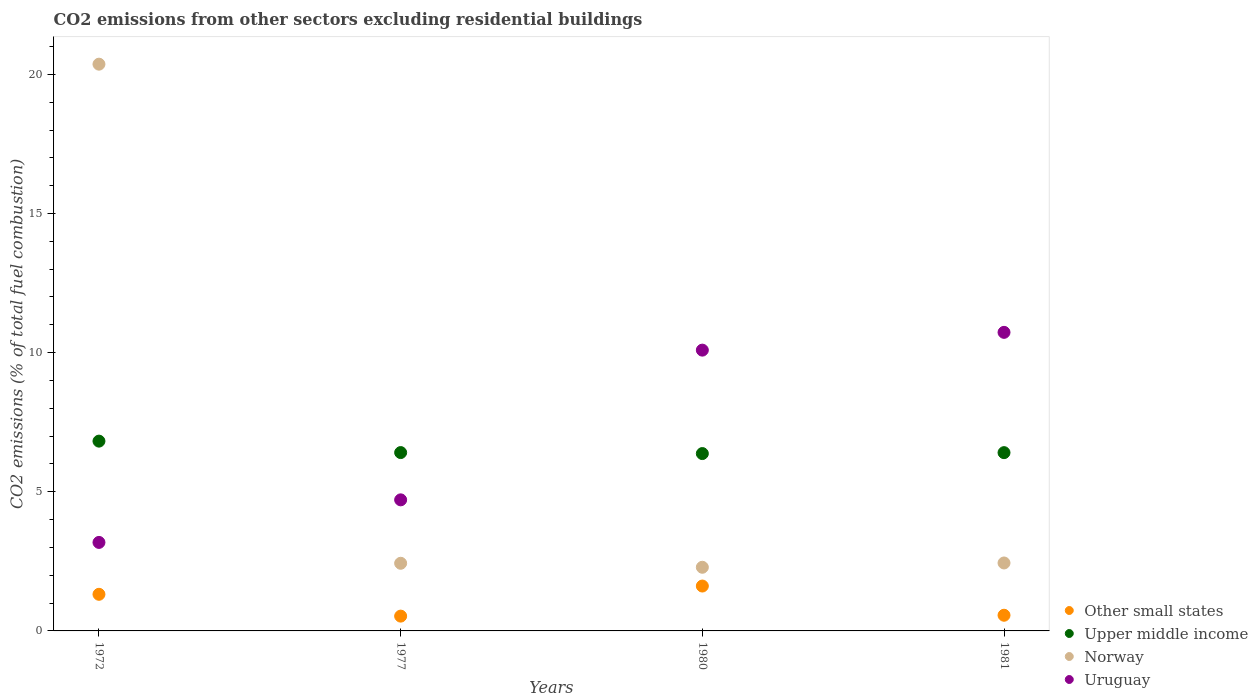How many different coloured dotlines are there?
Your answer should be very brief. 4. Is the number of dotlines equal to the number of legend labels?
Your response must be concise. Yes. What is the total CO2 emitted in Other small states in 1980?
Ensure brevity in your answer.  1.61. Across all years, what is the maximum total CO2 emitted in Norway?
Offer a terse response. 20.37. Across all years, what is the minimum total CO2 emitted in Other small states?
Make the answer very short. 0.53. In which year was the total CO2 emitted in Other small states maximum?
Provide a succinct answer. 1980. In which year was the total CO2 emitted in Uruguay minimum?
Provide a short and direct response. 1972. What is the total total CO2 emitted in Other small states in the graph?
Make the answer very short. 4.02. What is the difference between the total CO2 emitted in Other small states in 1972 and that in 1977?
Keep it short and to the point. 0.78. What is the difference between the total CO2 emitted in Norway in 1980 and the total CO2 emitted in Upper middle income in 1977?
Provide a short and direct response. -4.12. What is the average total CO2 emitted in Upper middle income per year?
Ensure brevity in your answer.  6.5. In the year 1972, what is the difference between the total CO2 emitted in Upper middle income and total CO2 emitted in Norway?
Keep it short and to the point. -13.55. What is the ratio of the total CO2 emitted in Uruguay in 1972 to that in 1980?
Make the answer very short. 0.32. Is the total CO2 emitted in Upper middle income in 1972 less than that in 1980?
Offer a very short reply. No. What is the difference between the highest and the second highest total CO2 emitted in Other small states?
Keep it short and to the point. 0.3. What is the difference between the highest and the lowest total CO2 emitted in Norway?
Give a very brief answer. 18.08. In how many years, is the total CO2 emitted in Upper middle income greater than the average total CO2 emitted in Upper middle income taken over all years?
Provide a succinct answer. 1. Is it the case that in every year, the sum of the total CO2 emitted in Upper middle income and total CO2 emitted in Norway  is greater than the total CO2 emitted in Other small states?
Give a very brief answer. Yes. Is the total CO2 emitted in Norway strictly less than the total CO2 emitted in Uruguay over the years?
Give a very brief answer. No. How many dotlines are there?
Make the answer very short. 4. Does the graph contain grids?
Keep it short and to the point. No. Where does the legend appear in the graph?
Your answer should be compact. Bottom right. What is the title of the graph?
Your answer should be compact. CO2 emissions from other sectors excluding residential buildings. Does "East Asia (developing only)" appear as one of the legend labels in the graph?
Provide a short and direct response. No. What is the label or title of the X-axis?
Provide a short and direct response. Years. What is the label or title of the Y-axis?
Your answer should be very brief. CO2 emissions (% of total fuel combustion). What is the CO2 emissions (% of total fuel combustion) of Other small states in 1972?
Offer a terse response. 1.32. What is the CO2 emissions (% of total fuel combustion) of Upper middle income in 1972?
Your answer should be compact. 6.82. What is the CO2 emissions (% of total fuel combustion) in Norway in 1972?
Provide a short and direct response. 20.37. What is the CO2 emissions (% of total fuel combustion) in Uruguay in 1972?
Offer a terse response. 3.18. What is the CO2 emissions (% of total fuel combustion) in Other small states in 1977?
Your response must be concise. 0.53. What is the CO2 emissions (% of total fuel combustion) in Upper middle income in 1977?
Offer a terse response. 6.41. What is the CO2 emissions (% of total fuel combustion) of Norway in 1977?
Your answer should be very brief. 2.43. What is the CO2 emissions (% of total fuel combustion) in Uruguay in 1977?
Keep it short and to the point. 4.71. What is the CO2 emissions (% of total fuel combustion) in Other small states in 1980?
Your answer should be compact. 1.61. What is the CO2 emissions (% of total fuel combustion) of Upper middle income in 1980?
Your answer should be very brief. 6.37. What is the CO2 emissions (% of total fuel combustion) of Norway in 1980?
Keep it short and to the point. 2.29. What is the CO2 emissions (% of total fuel combustion) of Uruguay in 1980?
Provide a succinct answer. 10.09. What is the CO2 emissions (% of total fuel combustion) of Other small states in 1981?
Offer a very short reply. 0.56. What is the CO2 emissions (% of total fuel combustion) in Upper middle income in 1981?
Your response must be concise. 6.41. What is the CO2 emissions (% of total fuel combustion) of Norway in 1981?
Make the answer very short. 2.44. What is the CO2 emissions (% of total fuel combustion) of Uruguay in 1981?
Offer a terse response. 10.73. Across all years, what is the maximum CO2 emissions (% of total fuel combustion) in Other small states?
Make the answer very short. 1.61. Across all years, what is the maximum CO2 emissions (% of total fuel combustion) of Upper middle income?
Offer a terse response. 6.82. Across all years, what is the maximum CO2 emissions (% of total fuel combustion) in Norway?
Make the answer very short. 20.37. Across all years, what is the maximum CO2 emissions (% of total fuel combustion) in Uruguay?
Make the answer very short. 10.73. Across all years, what is the minimum CO2 emissions (% of total fuel combustion) of Other small states?
Ensure brevity in your answer.  0.53. Across all years, what is the minimum CO2 emissions (% of total fuel combustion) of Upper middle income?
Provide a short and direct response. 6.37. Across all years, what is the minimum CO2 emissions (% of total fuel combustion) of Norway?
Ensure brevity in your answer.  2.29. Across all years, what is the minimum CO2 emissions (% of total fuel combustion) of Uruguay?
Give a very brief answer. 3.18. What is the total CO2 emissions (% of total fuel combustion) in Other small states in the graph?
Your response must be concise. 4.02. What is the total CO2 emissions (% of total fuel combustion) in Upper middle income in the graph?
Your response must be concise. 26.01. What is the total CO2 emissions (% of total fuel combustion) of Norway in the graph?
Make the answer very short. 27.53. What is the total CO2 emissions (% of total fuel combustion) in Uruguay in the graph?
Your answer should be compact. 28.71. What is the difference between the CO2 emissions (% of total fuel combustion) in Other small states in 1972 and that in 1977?
Ensure brevity in your answer.  0.78. What is the difference between the CO2 emissions (% of total fuel combustion) in Upper middle income in 1972 and that in 1977?
Ensure brevity in your answer.  0.41. What is the difference between the CO2 emissions (% of total fuel combustion) of Norway in 1972 and that in 1977?
Your answer should be very brief. 17.93. What is the difference between the CO2 emissions (% of total fuel combustion) in Uruguay in 1972 and that in 1977?
Make the answer very short. -1.53. What is the difference between the CO2 emissions (% of total fuel combustion) of Other small states in 1972 and that in 1980?
Provide a succinct answer. -0.3. What is the difference between the CO2 emissions (% of total fuel combustion) of Upper middle income in 1972 and that in 1980?
Give a very brief answer. 0.45. What is the difference between the CO2 emissions (% of total fuel combustion) of Norway in 1972 and that in 1980?
Offer a terse response. 18.08. What is the difference between the CO2 emissions (% of total fuel combustion) of Uruguay in 1972 and that in 1980?
Your response must be concise. -6.91. What is the difference between the CO2 emissions (% of total fuel combustion) of Other small states in 1972 and that in 1981?
Provide a short and direct response. 0.75. What is the difference between the CO2 emissions (% of total fuel combustion) in Upper middle income in 1972 and that in 1981?
Your response must be concise. 0.41. What is the difference between the CO2 emissions (% of total fuel combustion) of Norway in 1972 and that in 1981?
Provide a succinct answer. 17.92. What is the difference between the CO2 emissions (% of total fuel combustion) in Uruguay in 1972 and that in 1981?
Offer a very short reply. -7.55. What is the difference between the CO2 emissions (% of total fuel combustion) of Other small states in 1977 and that in 1980?
Your response must be concise. -1.08. What is the difference between the CO2 emissions (% of total fuel combustion) in Upper middle income in 1977 and that in 1980?
Make the answer very short. 0.04. What is the difference between the CO2 emissions (% of total fuel combustion) of Norway in 1977 and that in 1980?
Keep it short and to the point. 0.14. What is the difference between the CO2 emissions (% of total fuel combustion) of Uruguay in 1977 and that in 1980?
Your answer should be very brief. -5.38. What is the difference between the CO2 emissions (% of total fuel combustion) in Other small states in 1977 and that in 1981?
Your response must be concise. -0.03. What is the difference between the CO2 emissions (% of total fuel combustion) of Upper middle income in 1977 and that in 1981?
Provide a short and direct response. 0. What is the difference between the CO2 emissions (% of total fuel combustion) of Norway in 1977 and that in 1981?
Your answer should be very brief. -0.01. What is the difference between the CO2 emissions (% of total fuel combustion) of Uruguay in 1977 and that in 1981?
Offer a very short reply. -6.02. What is the difference between the CO2 emissions (% of total fuel combustion) of Other small states in 1980 and that in 1981?
Your response must be concise. 1.05. What is the difference between the CO2 emissions (% of total fuel combustion) of Upper middle income in 1980 and that in 1981?
Offer a terse response. -0.03. What is the difference between the CO2 emissions (% of total fuel combustion) of Norway in 1980 and that in 1981?
Your answer should be compact. -0.15. What is the difference between the CO2 emissions (% of total fuel combustion) of Uruguay in 1980 and that in 1981?
Your answer should be very brief. -0.64. What is the difference between the CO2 emissions (% of total fuel combustion) of Other small states in 1972 and the CO2 emissions (% of total fuel combustion) of Upper middle income in 1977?
Offer a terse response. -5.09. What is the difference between the CO2 emissions (% of total fuel combustion) in Other small states in 1972 and the CO2 emissions (% of total fuel combustion) in Norway in 1977?
Make the answer very short. -1.12. What is the difference between the CO2 emissions (% of total fuel combustion) of Other small states in 1972 and the CO2 emissions (% of total fuel combustion) of Uruguay in 1977?
Ensure brevity in your answer.  -3.39. What is the difference between the CO2 emissions (% of total fuel combustion) of Upper middle income in 1972 and the CO2 emissions (% of total fuel combustion) of Norway in 1977?
Offer a very short reply. 4.39. What is the difference between the CO2 emissions (% of total fuel combustion) of Upper middle income in 1972 and the CO2 emissions (% of total fuel combustion) of Uruguay in 1977?
Your answer should be compact. 2.11. What is the difference between the CO2 emissions (% of total fuel combustion) in Norway in 1972 and the CO2 emissions (% of total fuel combustion) in Uruguay in 1977?
Provide a succinct answer. 15.66. What is the difference between the CO2 emissions (% of total fuel combustion) of Other small states in 1972 and the CO2 emissions (% of total fuel combustion) of Upper middle income in 1980?
Make the answer very short. -5.06. What is the difference between the CO2 emissions (% of total fuel combustion) in Other small states in 1972 and the CO2 emissions (% of total fuel combustion) in Norway in 1980?
Provide a succinct answer. -0.97. What is the difference between the CO2 emissions (% of total fuel combustion) of Other small states in 1972 and the CO2 emissions (% of total fuel combustion) of Uruguay in 1980?
Provide a short and direct response. -8.77. What is the difference between the CO2 emissions (% of total fuel combustion) of Upper middle income in 1972 and the CO2 emissions (% of total fuel combustion) of Norway in 1980?
Your answer should be compact. 4.53. What is the difference between the CO2 emissions (% of total fuel combustion) in Upper middle income in 1972 and the CO2 emissions (% of total fuel combustion) in Uruguay in 1980?
Your answer should be very brief. -3.27. What is the difference between the CO2 emissions (% of total fuel combustion) in Norway in 1972 and the CO2 emissions (% of total fuel combustion) in Uruguay in 1980?
Your answer should be very brief. 10.28. What is the difference between the CO2 emissions (% of total fuel combustion) of Other small states in 1972 and the CO2 emissions (% of total fuel combustion) of Upper middle income in 1981?
Give a very brief answer. -5.09. What is the difference between the CO2 emissions (% of total fuel combustion) of Other small states in 1972 and the CO2 emissions (% of total fuel combustion) of Norway in 1981?
Make the answer very short. -1.13. What is the difference between the CO2 emissions (% of total fuel combustion) in Other small states in 1972 and the CO2 emissions (% of total fuel combustion) in Uruguay in 1981?
Make the answer very short. -9.41. What is the difference between the CO2 emissions (% of total fuel combustion) of Upper middle income in 1972 and the CO2 emissions (% of total fuel combustion) of Norway in 1981?
Ensure brevity in your answer.  4.38. What is the difference between the CO2 emissions (% of total fuel combustion) in Upper middle income in 1972 and the CO2 emissions (% of total fuel combustion) in Uruguay in 1981?
Provide a short and direct response. -3.91. What is the difference between the CO2 emissions (% of total fuel combustion) in Norway in 1972 and the CO2 emissions (% of total fuel combustion) in Uruguay in 1981?
Offer a terse response. 9.64. What is the difference between the CO2 emissions (% of total fuel combustion) of Other small states in 1977 and the CO2 emissions (% of total fuel combustion) of Upper middle income in 1980?
Your answer should be very brief. -5.84. What is the difference between the CO2 emissions (% of total fuel combustion) in Other small states in 1977 and the CO2 emissions (% of total fuel combustion) in Norway in 1980?
Your answer should be very brief. -1.76. What is the difference between the CO2 emissions (% of total fuel combustion) of Other small states in 1977 and the CO2 emissions (% of total fuel combustion) of Uruguay in 1980?
Give a very brief answer. -9.56. What is the difference between the CO2 emissions (% of total fuel combustion) of Upper middle income in 1977 and the CO2 emissions (% of total fuel combustion) of Norway in 1980?
Your answer should be very brief. 4.12. What is the difference between the CO2 emissions (% of total fuel combustion) in Upper middle income in 1977 and the CO2 emissions (% of total fuel combustion) in Uruguay in 1980?
Ensure brevity in your answer.  -3.68. What is the difference between the CO2 emissions (% of total fuel combustion) of Norway in 1977 and the CO2 emissions (% of total fuel combustion) of Uruguay in 1980?
Provide a short and direct response. -7.66. What is the difference between the CO2 emissions (% of total fuel combustion) in Other small states in 1977 and the CO2 emissions (% of total fuel combustion) in Upper middle income in 1981?
Keep it short and to the point. -5.87. What is the difference between the CO2 emissions (% of total fuel combustion) of Other small states in 1977 and the CO2 emissions (% of total fuel combustion) of Norway in 1981?
Offer a very short reply. -1.91. What is the difference between the CO2 emissions (% of total fuel combustion) of Other small states in 1977 and the CO2 emissions (% of total fuel combustion) of Uruguay in 1981?
Your answer should be very brief. -10.2. What is the difference between the CO2 emissions (% of total fuel combustion) of Upper middle income in 1977 and the CO2 emissions (% of total fuel combustion) of Norway in 1981?
Make the answer very short. 3.97. What is the difference between the CO2 emissions (% of total fuel combustion) of Upper middle income in 1977 and the CO2 emissions (% of total fuel combustion) of Uruguay in 1981?
Your answer should be compact. -4.32. What is the difference between the CO2 emissions (% of total fuel combustion) in Norway in 1977 and the CO2 emissions (% of total fuel combustion) in Uruguay in 1981?
Keep it short and to the point. -8.3. What is the difference between the CO2 emissions (% of total fuel combustion) of Other small states in 1980 and the CO2 emissions (% of total fuel combustion) of Upper middle income in 1981?
Keep it short and to the point. -4.79. What is the difference between the CO2 emissions (% of total fuel combustion) in Other small states in 1980 and the CO2 emissions (% of total fuel combustion) in Norway in 1981?
Your answer should be compact. -0.83. What is the difference between the CO2 emissions (% of total fuel combustion) in Other small states in 1980 and the CO2 emissions (% of total fuel combustion) in Uruguay in 1981?
Provide a short and direct response. -9.12. What is the difference between the CO2 emissions (% of total fuel combustion) in Upper middle income in 1980 and the CO2 emissions (% of total fuel combustion) in Norway in 1981?
Your response must be concise. 3.93. What is the difference between the CO2 emissions (% of total fuel combustion) of Upper middle income in 1980 and the CO2 emissions (% of total fuel combustion) of Uruguay in 1981?
Provide a succinct answer. -4.36. What is the difference between the CO2 emissions (% of total fuel combustion) of Norway in 1980 and the CO2 emissions (% of total fuel combustion) of Uruguay in 1981?
Provide a short and direct response. -8.44. What is the average CO2 emissions (% of total fuel combustion) in Other small states per year?
Your response must be concise. 1.01. What is the average CO2 emissions (% of total fuel combustion) in Upper middle income per year?
Ensure brevity in your answer.  6.5. What is the average CO2 emissions (% of total fuel combustion) of Norway per year?
Make the answer very short. 6.88. What is the average CO2 emissions (% of total fuel combustion) of Uruguay per year?
Offer a terse response. 7.18. In the year 1972, what is the difference between the CO2 emissions (% of total fuel combustion) of Other small states and CO2 emissions (% of total fuel combustion) of Upper middle income?
Your answer should be very brief. -5.5. In the year 1972, what is the difference between the CO2 emissions (% of total fuel combustion) in Other small states and CO2 emissions (% of total fuel combustion) in Norway?
Your answer should be very brief. -19.05. In the year 1972, what is the difference between the CO2 emissions (% of total fuel combustion) of Other small states and CO2 emissions (% of total fuel combustion) of Uruguay?
Your answer should be compact. -1.86. In the year 1972, what is the difference between the CO2 emissions (% of total fuel combustion) in Upper middle income and CO2 emissions (% of total fuel combustion) in Norway?
Your answer should be very brief. -13.55. In the year 1972, what is the difference between the CO2 emissions (% of total fuel combustion) of Upper middle income and CO2 emissions (% of total fuel combustion) of Uruguay?
Provide a short and direct response. 3.64. In the year 1972, what is the difference between the CO2 emissions (% of total fuel combustion) in Norway and CO2 emissions (% of total fuel combustion) in Uruguay?
Provide a succinct answer. 17.19. In the year 1977, what is the difference between the CO2 emissions (% of total fuel combustion) in Other small states and CO2 emissions (% of total fuel combustion) in Upper middle income?
Your answer should be compact. -5.88. In the year 1977, what is the difference between the CO2 emissions (% of total fuel combustion) in Other small states and CO2 emissions (% of total fuel combustion) in Norway?
Give a very brief answer. -1.9. In the year 1977, what is the difference between the CO2 emissions (% of total fuel combustion) in Other small states and CO2 emissions (% of total fuel combustion) in Uruguay?
Your answer should be very brief. -4.18. In the year 1977, what is the difference between the CO2 emissions (% of total fuel combustion) of Upper middle income and CO2 emissions (% of total fuel combustion) of Norway?
Keep it short and to the point. 3.98. In the year 1977, what is the difference between the CO2 emissions (% of total fuel combustion) in Upper middle income and CO2 emissions (% of total fuel combustion) in Uruguay?
Provide a succinct answer. 1.7. In the year 1977, what is the difference between the CO2 emissions (% of total fuel combustion) of Norway and CO2 emissions (% of total fuel combustion) of Uruguay?
Offer a very short reply. -2.28. In the year 1980, what is the difference between the CO2 emissions (% of total fuel combustion) in Other small states and CO2 emissions (% of total fuel combustion) in Upper middle income?
Provide a succinct answer. -4.76. In the year 1980, what is the difference between the CO2 emissions (% of total fuel combustion) in Other small states and CO2 emissions (% of total fuel combustion) in Norway?
Your response must be concise. -0.67. In the year 1980, what is the difference between the CO2 emissions (% of total fuel combustion) in Other small states and CO2 emissions (% of total fuel combustion) in Uruguay?
Offer a terse response. -8.48. In the year 1980, what is the difference between the CO2 emissions (% of total fuel combustion) in Upper middle income and CO2 emissions (% of total fuel combustion) in Norway?
Make the answer very short. 4.09. In the year 1980, what is the difference between the CO2 emissions (% of total fuel combustion) in Upper middle income and CO2 emissions (% of total fuel combustion) in Uruguay?
Ensure brevity in your answer.  -3.72. In the year 1980, what is the difference between the CO2 emissions (% of total fuel combustion) of Norway and CO2 emissions (% of total fuel combustion) of Uruguay?
Your answer should be very brief. -7.8. In the year 1981, what is the difference between the CO2 emissions (% of total fuel combustion) in Other small states and CO2 emissions (% of total fuel combustion) in Upper middle income?
Offer a very short reply. -5.84. In the year 1981, what is the difference between the CO2 emissions (% of total fuel combustion) of Other small states and CO2 emissions (% of total fuel combustion) of Norway?
Your response must be concise. -1.88. In the year 1981, what is the difference between the CO2 emissions (% of total fuel combustion) of Other small states and CO2 emissions (% of total fuel combustion) of Uruguay?
Make the answer very short. -10.17. In the year 1981, what is the difference between the CO2 emissions (% of total fuel combustion) in Upper middle income and CO2 emissions (% of total fuel combustion) in Norway?
Your answer should be very brief. 3.96. In the year 1981, what is the difference between the CO2 emissions (% of total fuel combustion) in Upper middle income and CO2 emissions (% of total fuel combustion) in Uruguay?
Your answer should be compact. -4.32. In the year 1981, what is the difference between the CO2 emissions (% of total fuel combustion) in Norway and CO2 emissions (% of total fuel combustion) in Uruguay?
Provide a short and direct response. -8.29. What is the ratio of the CO2 emissions (% of total fuel combustion) in Other small states in 1972 to that in 1977?
Ensure brevity in your answer.  2.47. What is the ratio of the CO2 emissions (% of total fuel combustion) in Upper middle income in 1972 to that in 1977?
Keep it short and to the point. 1.06. What is the ratio of the CO2 emissions (% of total fuel combustion) in Norway in 1972 to that in 1977?
Offer a very short reply. 8.38. What is the ratio of the CO2 emissions (% of total fuel combustion) of Uruguay in 1972 to that in 1977?
Offer a very short reply. 0.68. What is the ratio of the CO2 emissions (% of total fuel combustion) of Other small states in 1972 to that in 1980?
Make the answer very short. 0.82. What is the ratio of the CO2 emissions (% of total fuel combustion) of Upper middle income in 1972 to that in 1980?
Your answer should be very brief. 1.07. What is the ratio of the CO2 emissions (% of total fuel combustion) of Norway in 1972 to that in 1980?
Your answer should be very brief. 8.9. What is the ratio of the CO2 emissions (% of total fuel combustion) of Uruguay in 1972 to that in 1980?
Your answer should be compact. 0.32. What is the ratio of the CO2 emissions (% of total fuel combustion) in Other small states in 1972 to that in 1981?
Offer a terse response. 2.34. What is the ratio of the CO2 emissions (% of total fuel combustion) in Upper middle income in 1972 to that in 1981?
Your answer should be very brief. 1.06. What is the ratio of the CO2 emissions (% of total fuel combustion) of Norway in 1972 to that in 1981?
Make the answer very short. 8.34. What is the ratio of the CO2 emissions (% of total fuel combustion) in Uruguay in 1972 to that in 1981?
Offer a very short reply. 0.3. What is the ratio of the CO2 emissions (% of total fuel combustion) in Other small states in 1977 to that in 1980?
Your response must be concise. 0.33. What is the ratio of the CO2 emissions (% of total fuel combustion) in Upper middle income in 1977 to that in 1980?
Make the answer very short. 1.01. What is the ratio of the CO2 emissions (% of total fuel combustion) in Norway in 1977 to that in 1980?
Your answer should be very brief. 1.06. What is the ratio of the CO2 emissions (% of total fuel combustion) in Uruguay in 1977 to that in 1980?
Keep it short and to the point. 0.47. What is the ratio of the CO2 emissions (% of total fuel combustion) of Other small states in 1977 to that in 1981?
Provide a succinct answer. 0.94. What is the ratio of the CO2 emissions (% of total fuel combustion) in Uruguay in 1977 to that in 1981?
Your answer should be compact. 0.44. What is the ratio of the CO2 emissions (% of total fuel combustion) of Other small states in 1980 to that in 1981?
Your answer should be compact. 2.86. What is the ratio of the CO2 emissions (% of total fuel combustion) of Upper middle income in 1980 to that in 1981?
Make the answer very short. 0.99. What is the ratio of the CO2 emissions (% of total fuel combustion) of Norway in 1980 to that in 1981?
Provide a short and direct response. 0.94. What is the ratio of the CO2 emissions (% of total fuel combustion) in Uruguay in 1980 to that in 1981?
Your answer should be compact. 0.94. What is the difference between the highest and the second highest CO2 emissions (% of total fuel combustion) of Other small states?
Your answer should be compact. 0.3. What is the difference between the highest and the second highest CO2 emissions (% of total fuel combustion) in Upper middle income?
Your response must be concise. 0.41. What is the difference between the highest and the second highest CO2 emissions (% of total fuel combustion) in Norway?
Offer a terse response. 17.92. What is the difference between the highest and the second highest CO2 emissions (% of total fuel combustion) of Uruguay?
Give a very brief answer. 0.64. What is the difference between the highest and the lowest CO2 emissions (% of total fuel combustion) in Other small states?
Give a very brief answer. 1.08. What is the difference between the highest and the lowest CO2 emissions (% of total fuel combustion) in Upper middle income?
Offer a terse response. 0.45. What is the difference between the highest and the lowest CO2 emissions (% of total fuel combustion) of Norway?
Offer a very short reply. 18.08. What is the difference between the highest and the lowest CO2 emissions (% of total fuel combustion) in Uruguay?
Keep it short and to the point. 7.55. 